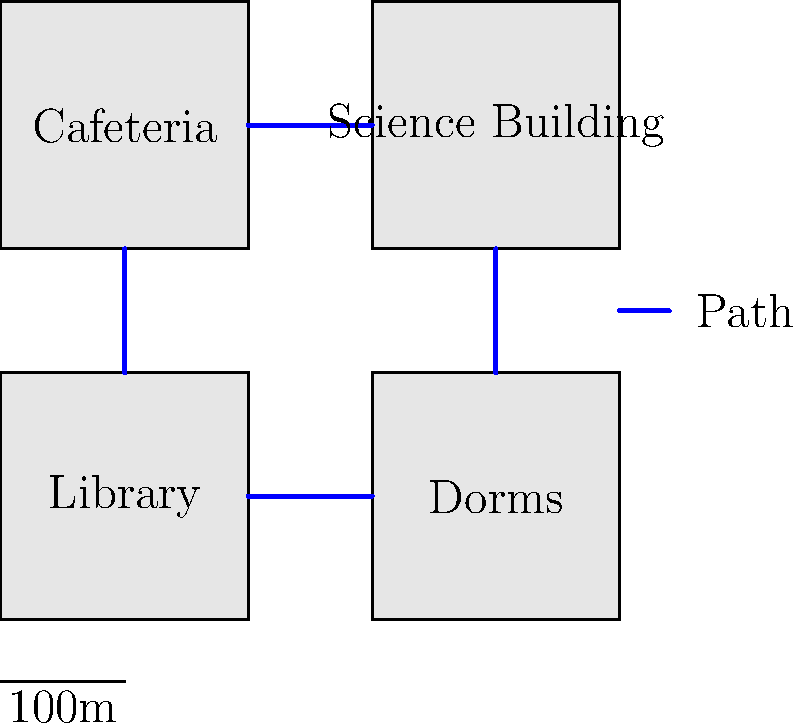Based on the simplified campus map provided, what is the shortest path a student would need to take to go from the Library to the Science Building? To find the shortest path from the Library to the Science Building, we need to analyze the map:

1. The Library is located in the bottom-left corner of the map.
2. The Science Building is located in the top-right corner of the map.
3. There are blue paths connecting the buildings.

The shortest path would be:
1. Start at the Library
2. Move right along the blue path to the Dorms
3. Move up along the blue path from the Dorms to the Science Building

This path involves only two segments and doesn't require going through any unnecessary buildings. Any other route would involve more segments or passing through additional buildings, making it longer.

The total distance can be estimated using the scale provided:
- Each building is approximately 200m wide (2 units on the map)
- The path from Library to Dorms is about 100m (1 unit)
- The path from Dorms to Science Building is about 200m (2 units)

So the total distance of the shortest path is approximately 300m.
Answer: Library → Dorms → Science Building (approximately 300m) 